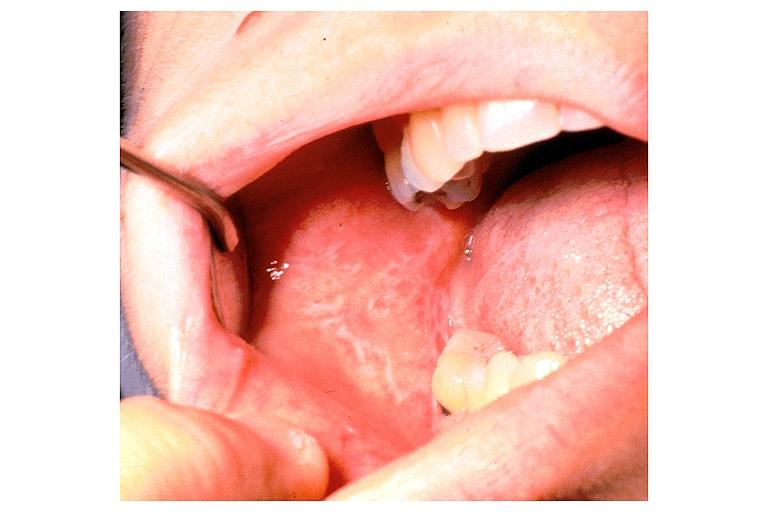does gross show lichen planus?
Answer the question using a single word or phrase. No 